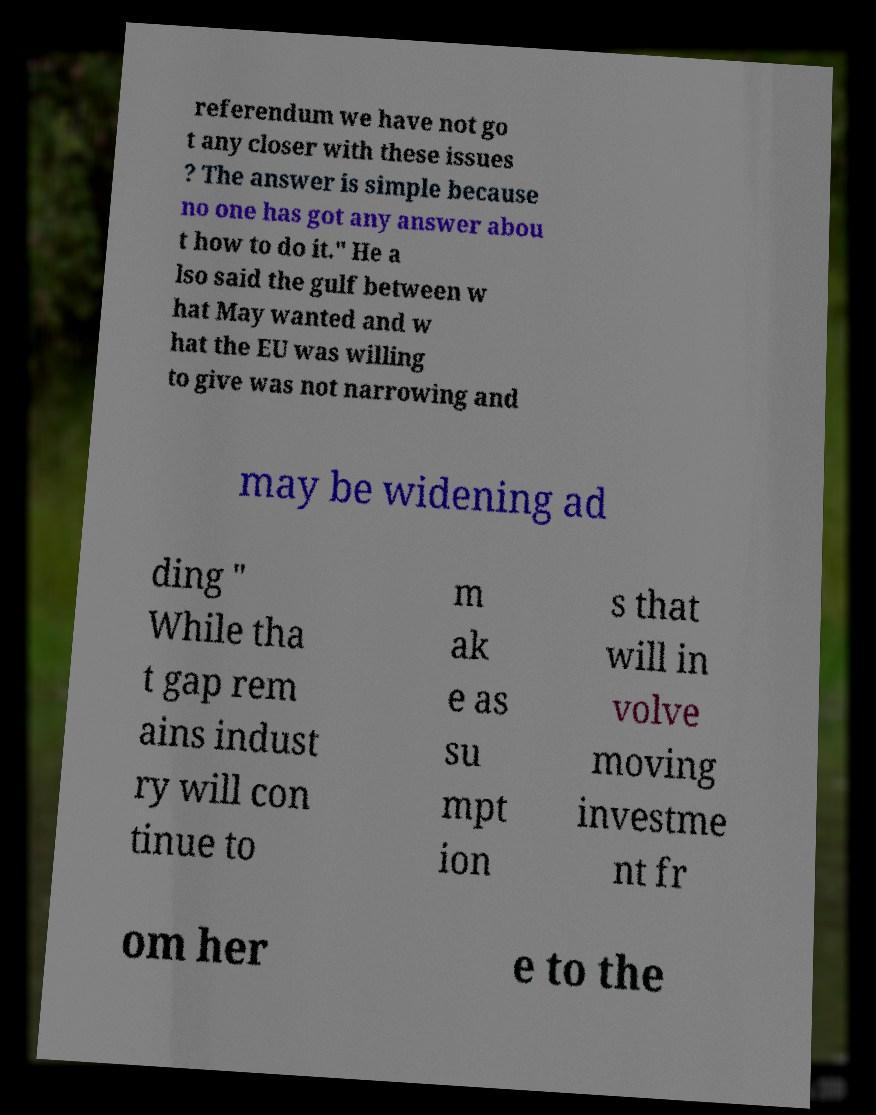There's text embedded in this image that I need extracted. Can you transcribe it verbatim? referendum we have not go t any closer with these issues ? The answer is simple because no one has got any answer abou t how to do it." He a lso said the gulf between w hat May wanted and w hat the EU was willing to give was not narrowing and may be widening ad ding " While tha t gap rem ains indust ry will con tinue to m ak e as su mpt ion s that will in volve moving investme nt fr om her e to the 